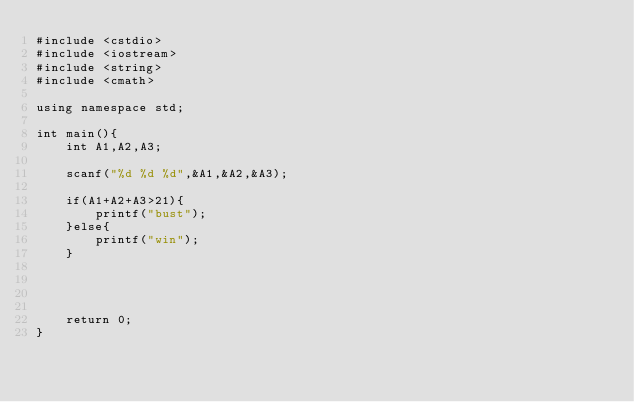Convert code to text. <code><loc_0><loc_0><loc_500><loc_500><_C++_>#include <cstdio>
#include <iostream>
#include <string>
#include <cmath>

using namespace std;

int main(){
	int A1,A2,A3;

	scanf("%d %d %d",&A1,&A2,&A3);

	if(A1+A2+A3>21){
		printf("bust");
	}else{
		printf("win");
	}




	return 0;
}</code> 